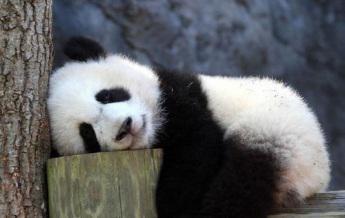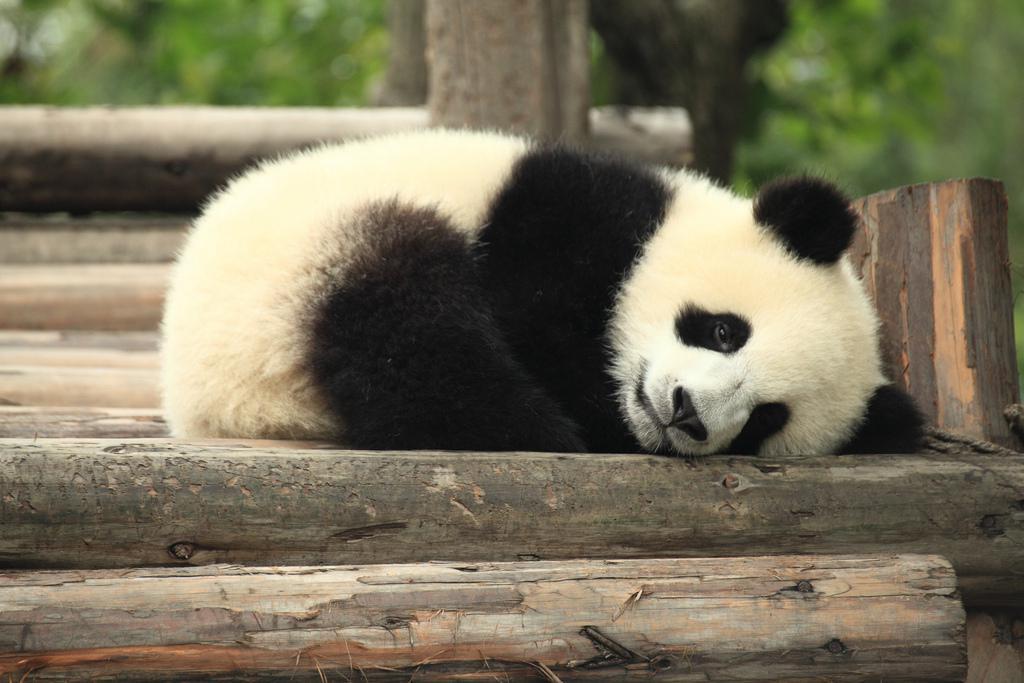The first image is the image on the left, the second image is the image on the right. Evaluate the accuracy of this statement regarding the images: "a panda is laying belly down on a tree limb". Is it true? Answer yes or no. No. 